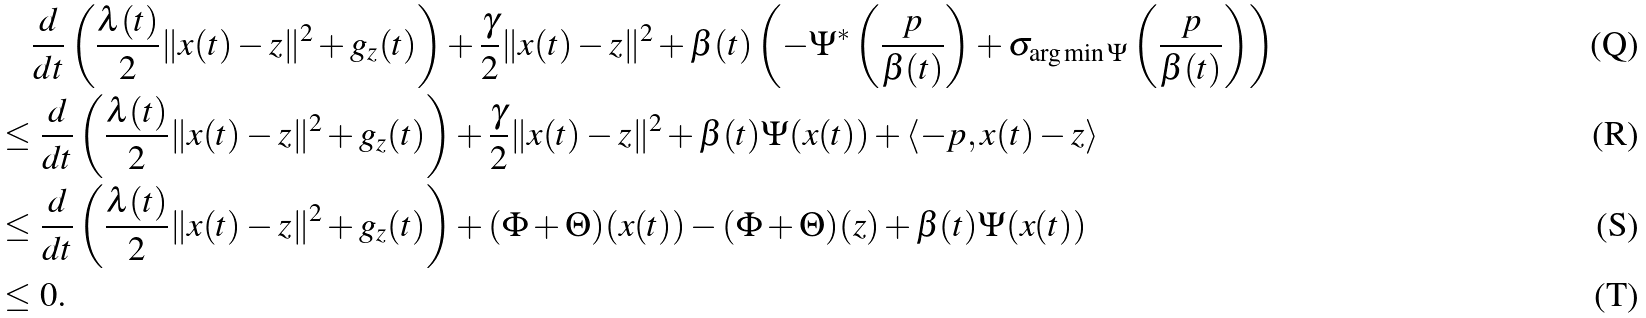Convert formula to latex. <formula><loc_0><loc_0><loc_500><loc_500>& \frac { d } { d t } \left ( \frac { \lambda ( t ) } { 2 } \| x ( t ) - z \| ^ { 2 } + g _ { z } ( t ) \right ) + \frac { \gamma } { 2 } \| x ( t ) - z \| ^ { 2 } + \beta ( t ) \left ( - \Psi ^ { * } \left ( \frac { p } { \beta ( t ) } \right ) + \sigma _ { \arg \min \Psi } \left ( \frac { p } { \beta ( t ) } \right ) \right ) \\ \leq & \ \frac { d } { d t } \left ( \frac { \lambda ( t ) } { 2 } \| x ( t ) - z \| ^ { 2 } + g _ { z } ( t ) \right ) + \frac { \gamma } { 2 } \| x ( t ) - z \| ^ { 2 } + \beta ( t ) \Psi ( x ( t ) ) + \langle - p , x ( t ) - z \rangle \\ \leq & \ \frac { d } { d t } \left ( \frac { \lambda ( t ) } { 2 } \| x ( t ) - z \| ^ { 2 } + g _ { z } ( t ) \right ) + ( \Phi + \Theta ) ( x ( t ) ) - ( \Phi + \Theta ) ( z ) + \beta ( t ) \Psi ( x ( t ) ) \\ \leq & \ 0 .</formula> 